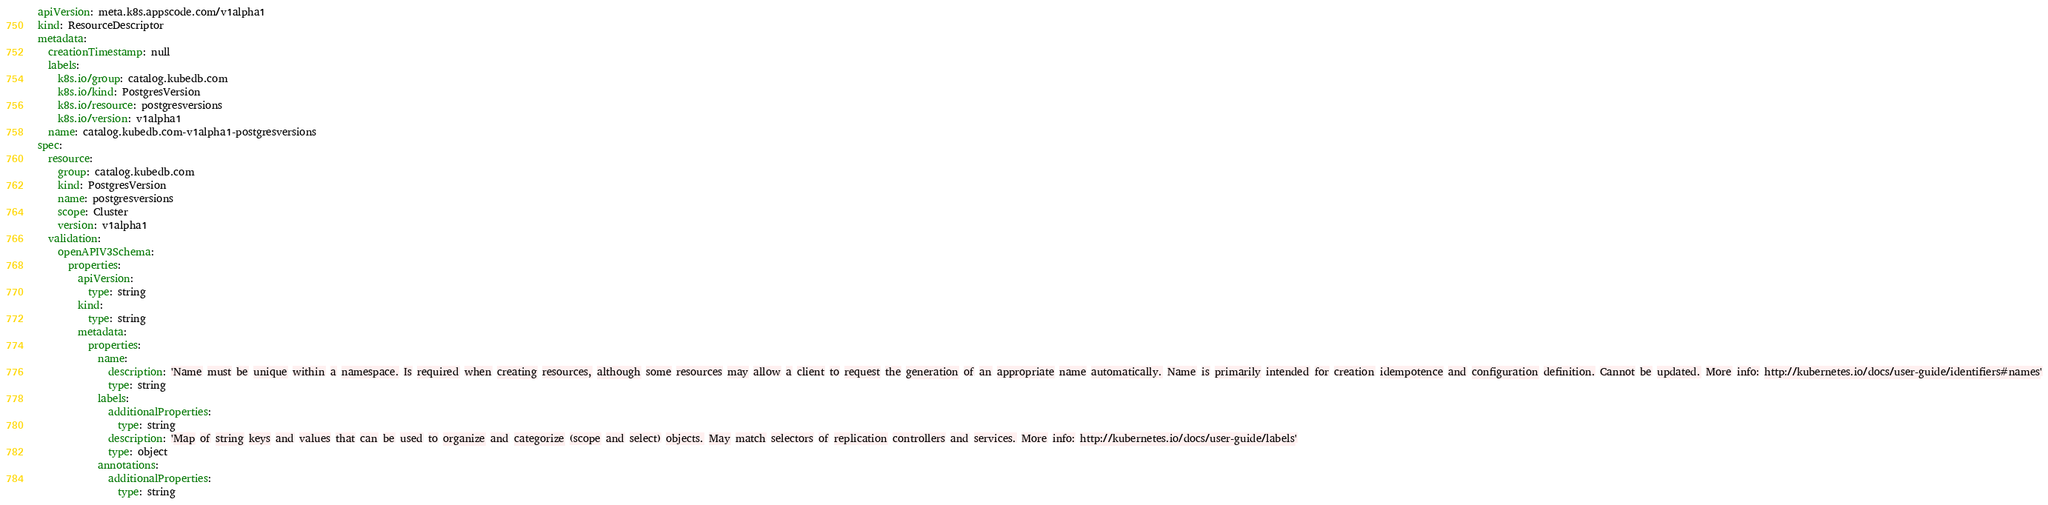<code> <loc_0><loc_0><loc_500><loc_500><_YAML_>apiVersion: meta.k8s.appscode.com/v1alpha1
kind: ResourceDescriptor
metadata:
  creationTimestamp: null
  labels:
    k8s.io/group: catalog.kubedb.com
    k8s.io/kind: PostgresVersion
    k8s.io/resource: postgresversions
    k8s.io/version: v1alpha1
  name: catalog.kubedb.com-v1alpha1-postgresversions
spec:
  resource:
    group: catalog.kubedb.com
    kind: PostgresVersion
    name: postgresversions
    scope: Cluster
    version: v1alpha1
  validation:
    openAPIV3Schema:
      properties:
        apiVersion:
          type: string
        kind:
          type: string
        metadata:
          properties:
            name:
              description: 'Name must be unique within a namespace. Is required when creating resources, although some resources may allow a client to request the generation of an appropriate name automatically. Name is primarily intended for creation idempotence and configuration definition. Cannot be updated. More info: http://kubernetes.io/docs/user-guide/identifiers#names'
              type: string
            labels:
              additionalProperties:
                type: string
              description: 'Map of string keys and values that can be used to organize and categorize (scope and select) objects. May match selectors of replication controllers and services. More info: http://kubernetes.io/docs/user-guide/labels'
              type: object
            annotations:
              additionalProperties:
                type: string</code> 